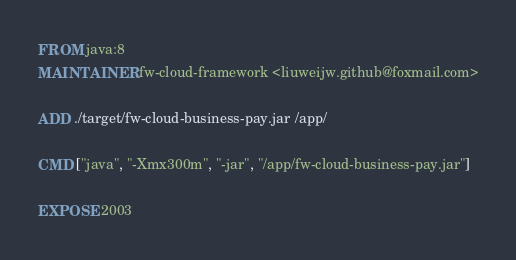<code> <loc_0><loc_0><loc_500><loc_500><_Dockerfile_>FROM java:8
MAINTAINER fw-cloud-framework <liuweijw.github@foxmail.com>

ADD ./target/fw-cloud-business-pay.jar /app/

CMD ["java", "-Xmx300m", "-jar", "/app/fw-cloud-business-pay.jar"]

EXPOSE 2003
</code> 